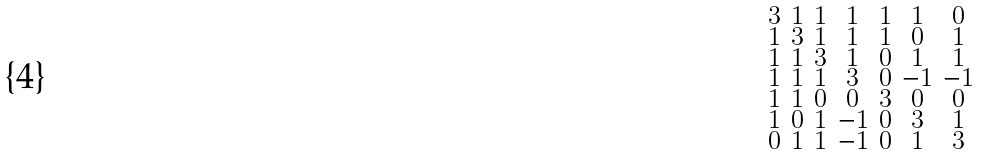Convert formula to latex. <formula><loc_0><loc_0><loc_500><loc_500>\begin{smallmatrix} 3 & 1 & 1 & 1 & 1 & 1 & 0 \\ 1 & 3 & 1 & 1 & 1 & 0 & 1 \\ 1 & 1 & 3 & 1 & 0 & 1 & 1 \\ 1 & 1 & 1 & 3 & 0 & - 1 & - 1 \\ 1 & 1 & 0 & 0 & 3 & 0 & 0 \\ 1 & 0 & 1 & - 1 & 0 & 3 & 1 \\ 0 & 1 & 1 & - 1 & 0 & 1 & 3 \end{smallmatrix}</formula> 